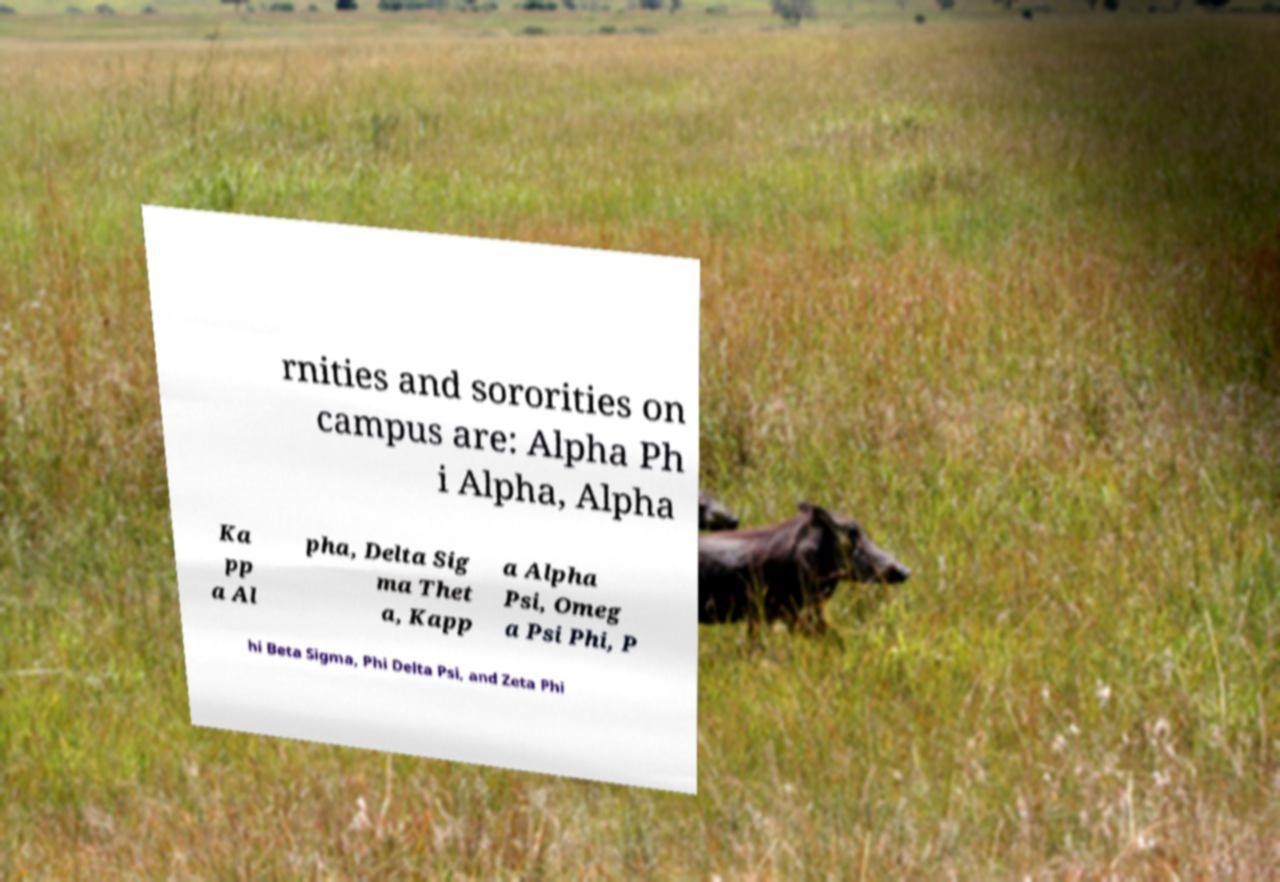Please read and relay the text visible in this image. What does it say? rnities and sororities on campus are: Alpha Ph i Alpha, Alpha Ka pp a Al pha, Delta Sig ma Thet a, Kapp a Alpha Psi, Omeg a Psi Phi, P hi Beta Sigma, Phi Delta Psi, and Zeta Phi 